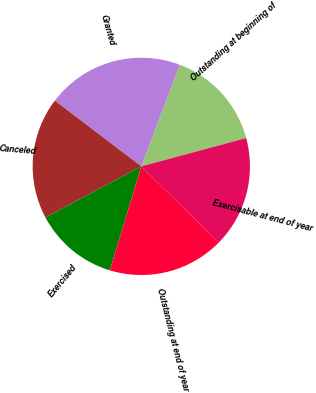<chart> <loc_0><loc_0><loc_500><loc_500><pie_chart><fcel>Outstanding at beginning of<fcel>Granted<fcel>Canceled<fcel>Exercised<fcel>Outstanding at end of year<fcel>Exercisable at end of year<nl><fcel>15.05%<fcel>20.41%<fcel>18.13%<fcel>12.53%<fcel>17.34%<fcel>16.55%<nl></chart> 